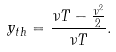<formula> <loc_0><loc_0><loc_500><loc_500>y _ { t h } = \frac { \nu T - \frac { \nu ^ { 2 } } { 2 } } { \nu T } .</formula> 